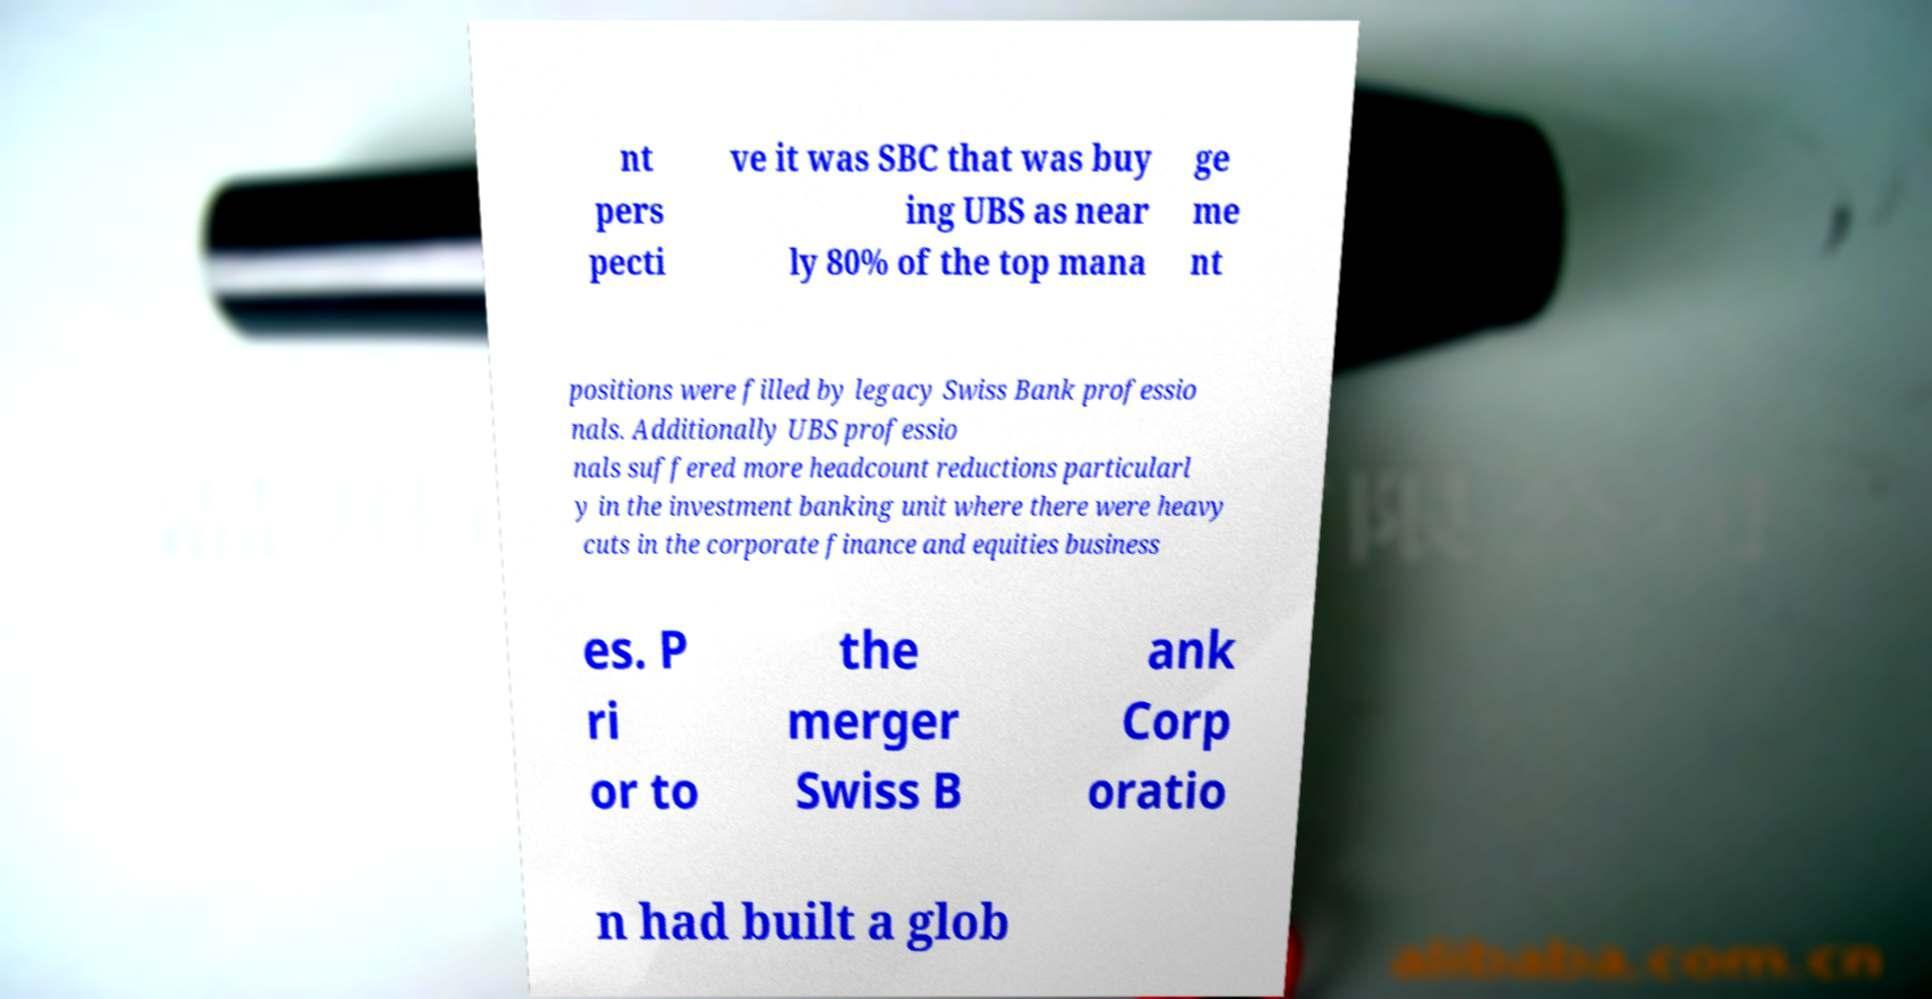Could you extract and type out the text from this image? nt pers pecti ve it was SBC that was buy ing UBS as near ly 80% of the top mana ge me nt positions were filled by legacy Swiss Bank professio nals. Additionally UBS professio nals suffered more headcount reductions particularl y in the investment banking unit where there were heavy cuts in the corporate finance and equities business es. P ri or to the merger Swiss B ank Corp oratio n had built a glob 